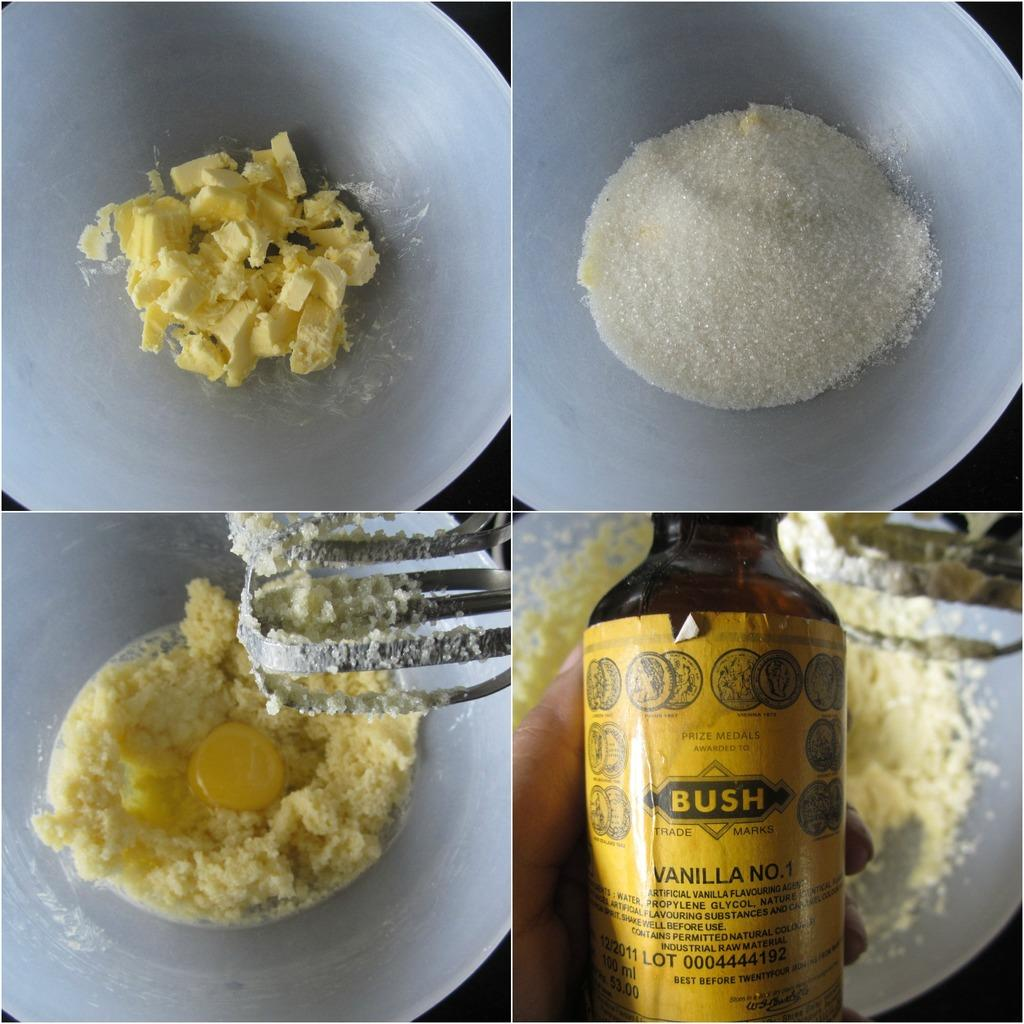Provide a one-sentence caption for the provided image. Collage of images including a person holding a BUSH bottle on the lower right. 